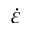Convert formula to latex. <formula><loc_0><loc_0><loc_500><loc_500>\dot { \varepsilon }</formula> 